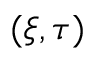Convert formula to latex. <formula><loc_0><loc_0><loc_500><loc_500>( \xi , \tau )</formula> 